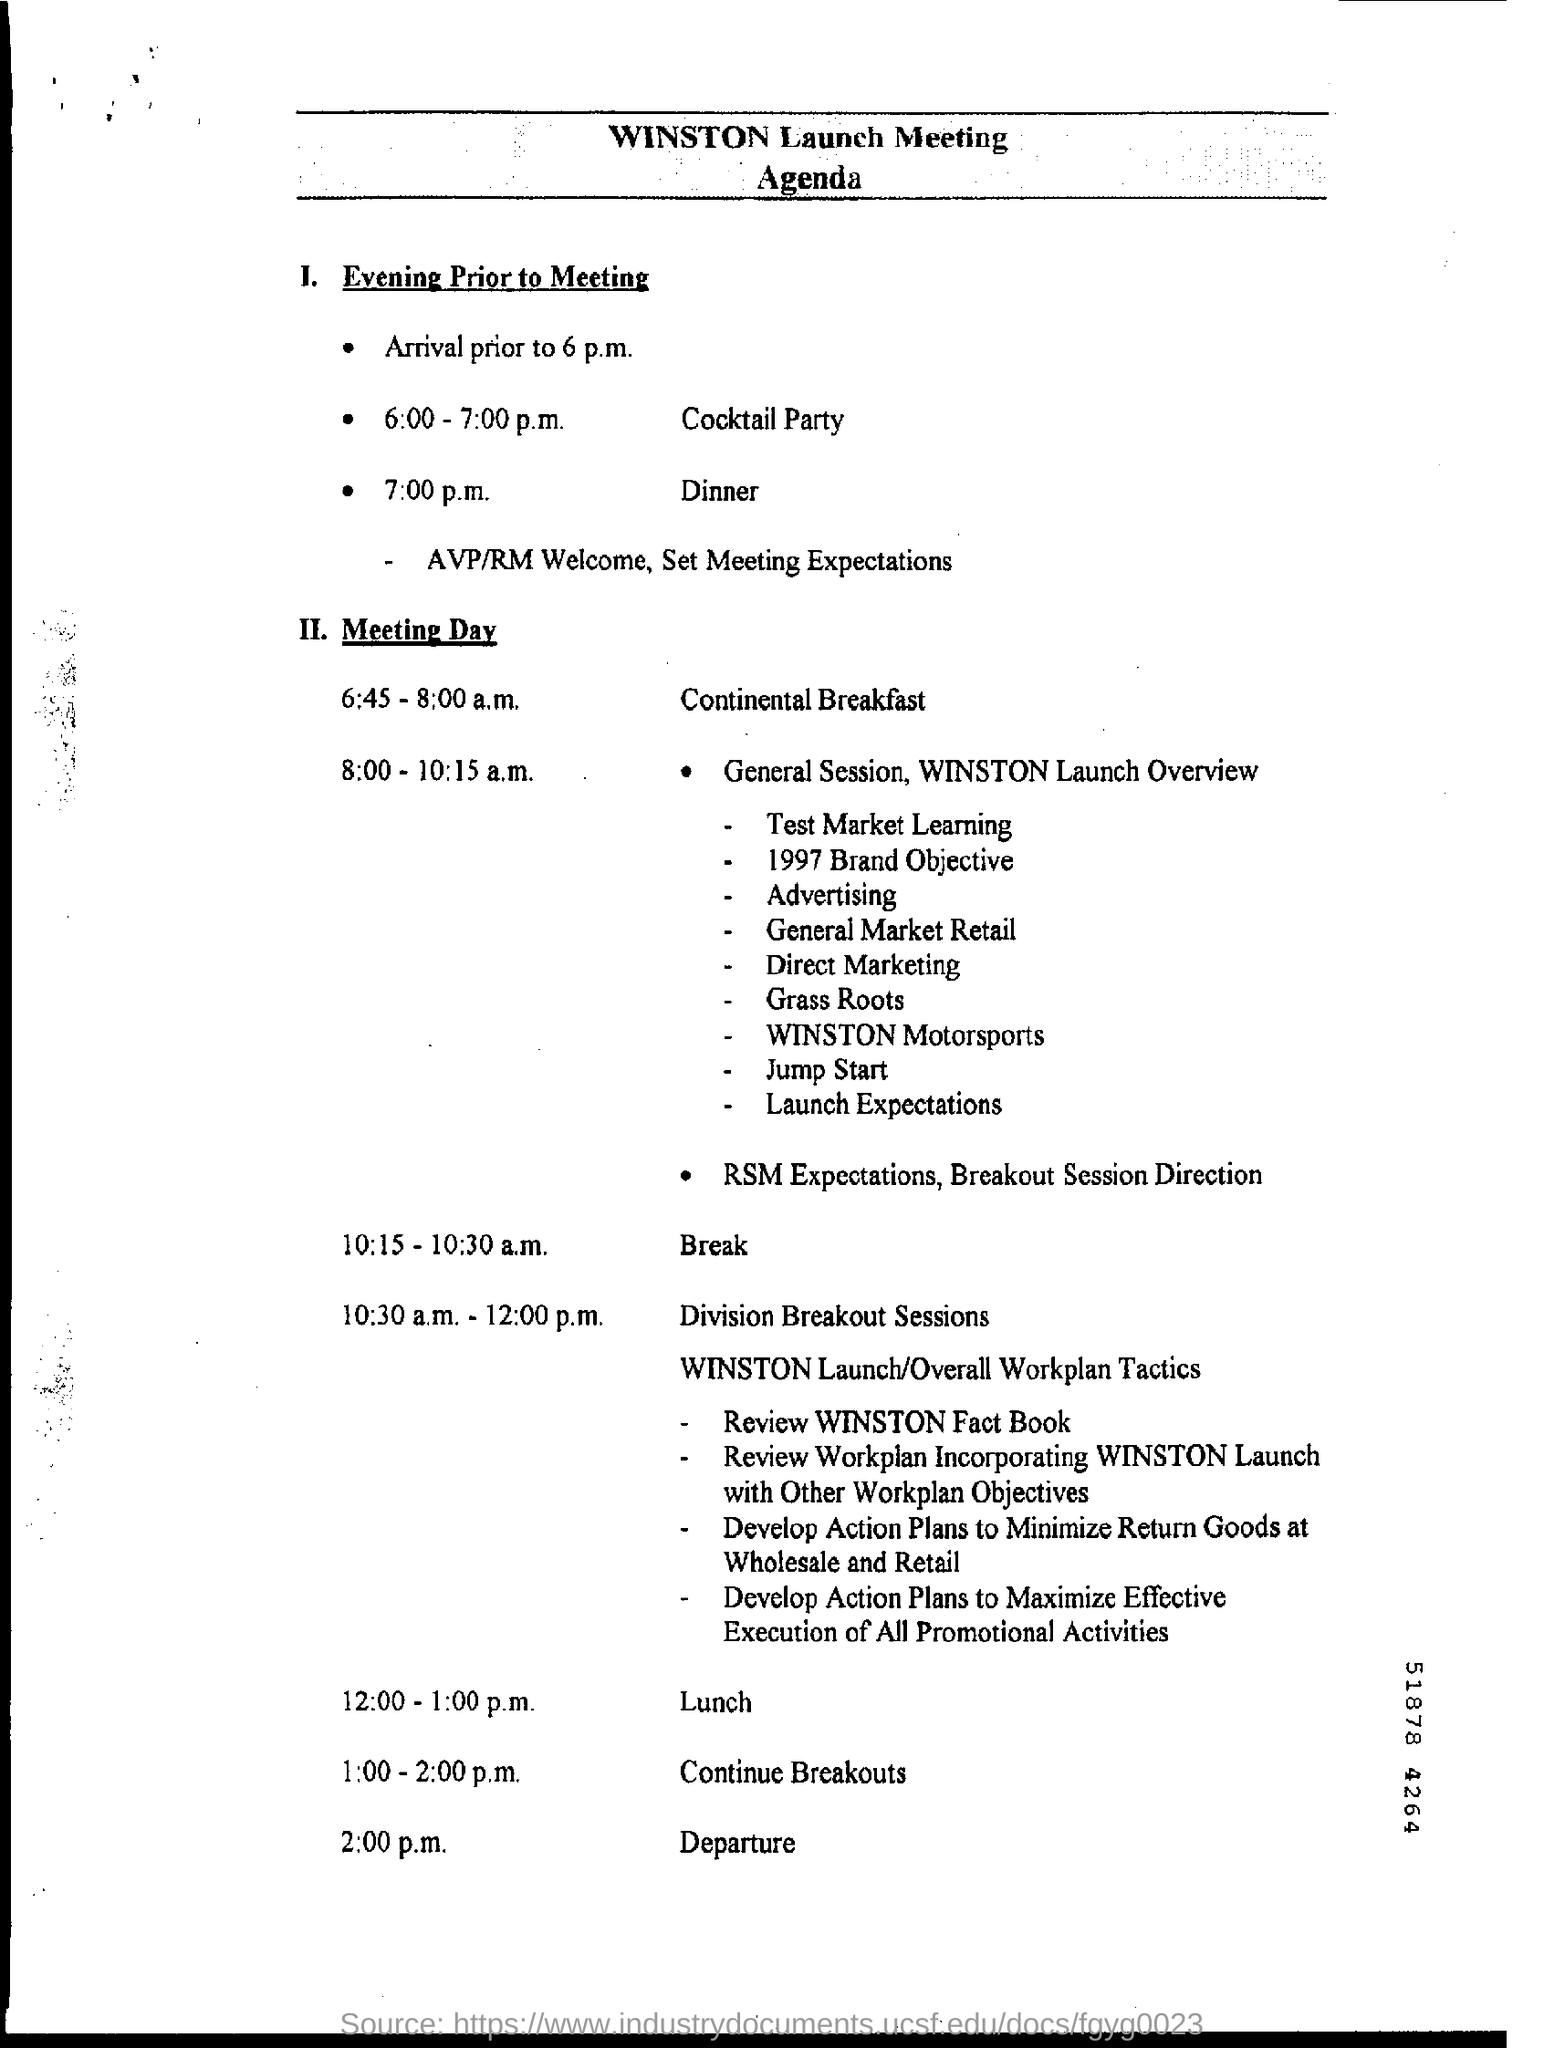When is the cocktail party?
Offer a very short reply. 6:00 - 7:00 p.m. What is the time for dinner?
Provide a succinct answer. 7:00 p.m. When is the continental breakfast?
Your answer should be compact. 6:45 - 8:00 a.m. What is the time for lunch?
Your answer should be compact. 12:00-1:00 p.m. 